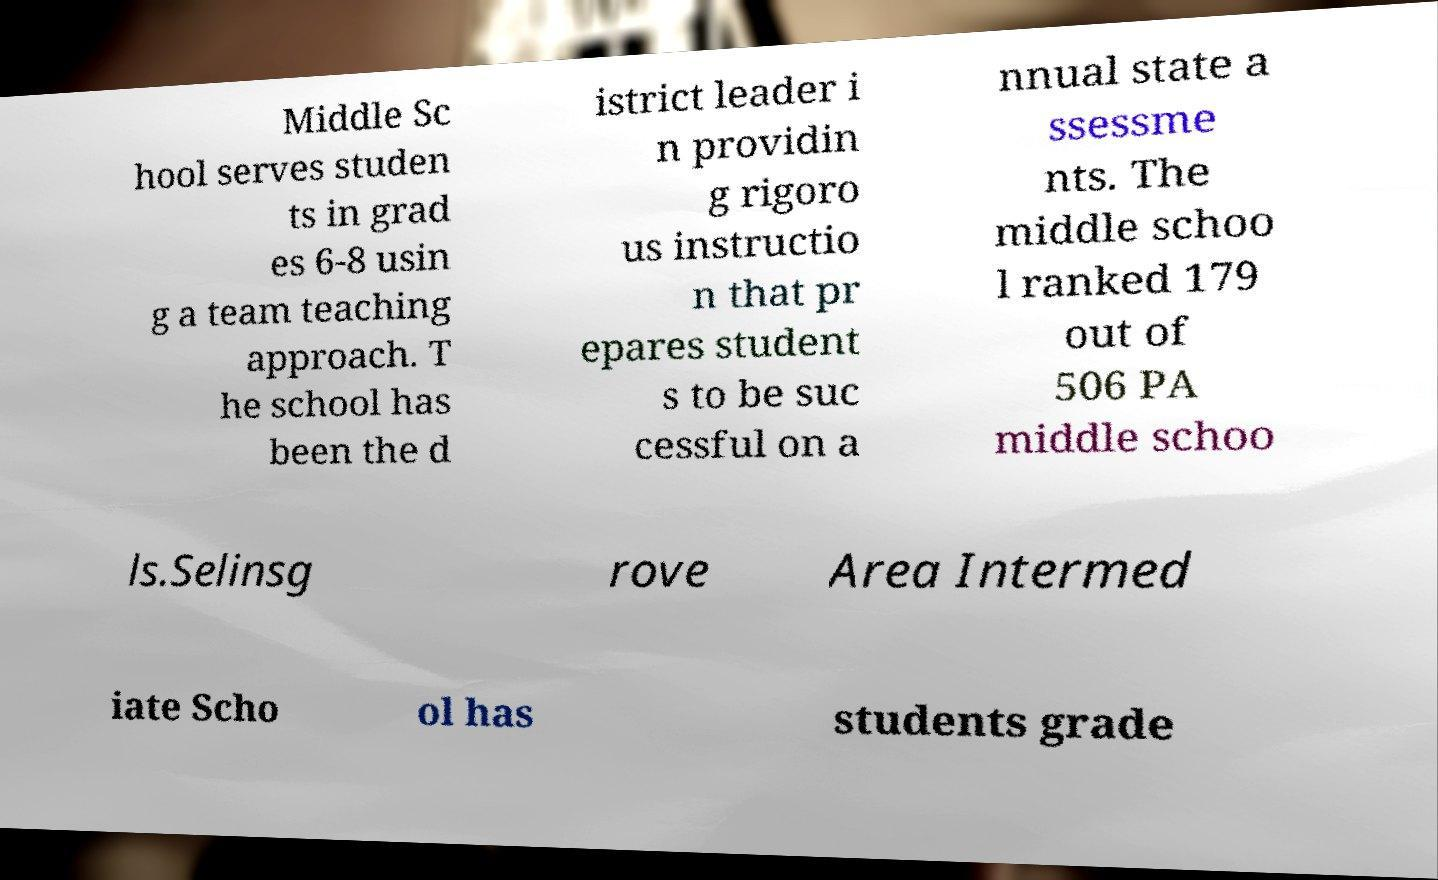Please read and relay the text visible in this image. What does it say? Middle Sc hool serves studen ts in grad es 6-8 usin g a team teaching approach. T he school has been the d istrict leader i n providin g rigoro us instructio n that pr epares student s to be suc cessful on a nnual state a ssessme nts. The middle schoo l ranked 179 out of 506 PA middle schoo ls.Selinsg rove Area Intermed iate Scho ol has students grade 